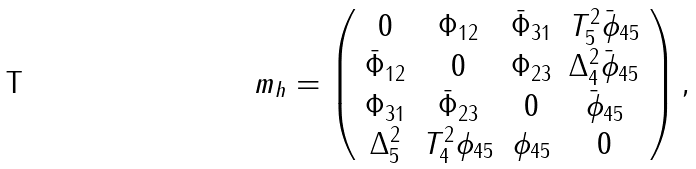Convert formula to latex. <formula><loc_0><loc_0><loc_500><loc_500>m _ { h } = \left ( \begin{array} { c c c c } 0 & \Phi _ { 1 2 } & \bar { \Phi } _ { 3 1 } & T _ { 5 } ^ { 2 } \bar { \phi } _ { 4 5 } \\ \bar { \Phi } _ { 1 2 } & 0 & \Phi _ { 2 3 } & \Delta _ { 4 } ^ { 2 } \bar { \phi } _ { 4 5 } \\ \Phi _ { 3 1 } & \bar { \Phi } _ { 2 3 } & 0 & \bar { \phi } _ { 4 5 } \\ \Delta _ { 5 } ^ { 2 } & T _ { 4 } ^ { 2 } \phi _ { 4 5 } & \phi _ { 4 5 } & 0 \end{array} \right ) ,</formula> 